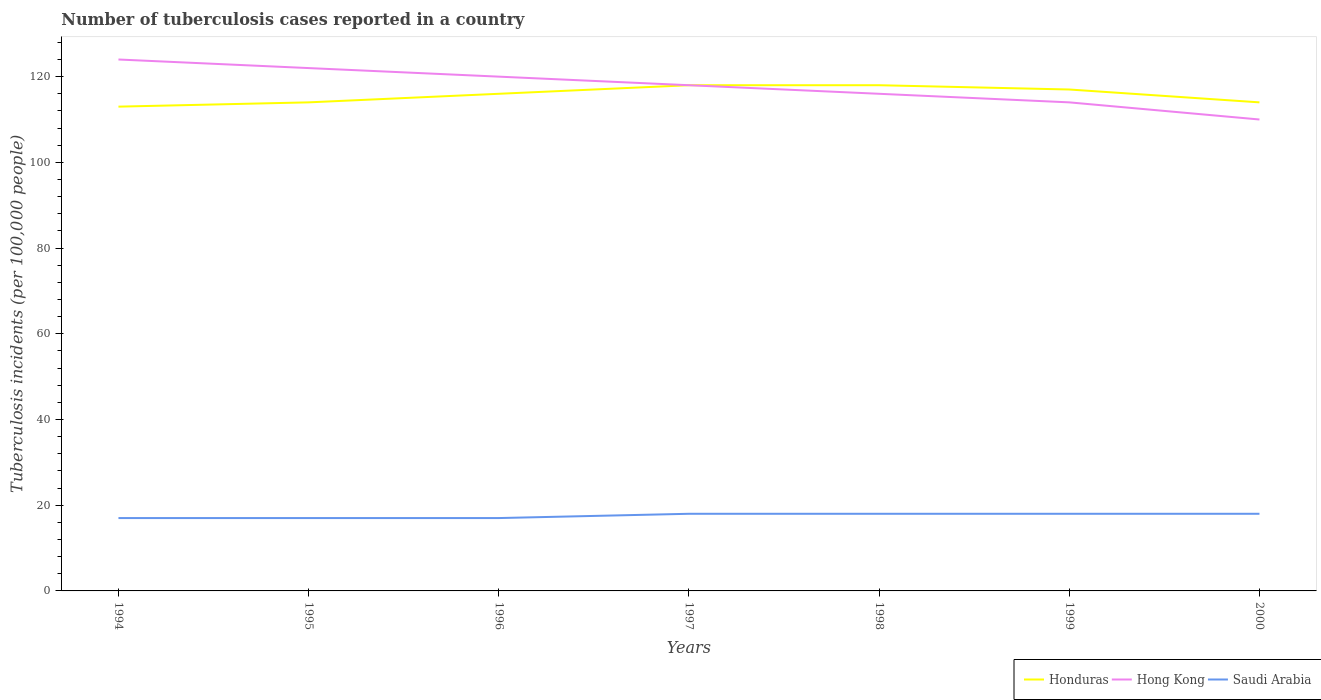How many different coloured lines are there?
Your answer should be compact. 3. Does the line corresponding to Honduras intersect with the line corresponding to Saudi Arabia?
Give a very brief answer. No. Is the number of lines equal to the number of legend labels?
Provide a succinct answer. Yes. Across all years, what is the maximum number of tuberculosis cases reported in in Hong Kong?
Make the answer very short. 110. What is the total number of tuberculosis cases reported in in Honduras in the graph?
Offer a very short reply. -1. What is the difference between the highest and the second highest number of tuberculosis cases reported in in Honduras?
Your answer should be compact. 5. Is the number of tuberculosis cases reported in in Hong Kong strictly greater than the number of tuberculosis cases reported in in Honduras over the years?
Provide a short and direct response. No. How many lines are there?
Offer a terse response. 3. What is the difference between two consecutive major ticks on the Y-axis?
Offer a terse response. 20. Are the values on the major ticks of Y-axis written in scientific E-notation?
Provide a succinct answer. No. Does the graph contain any zero values?
Your answer should be very brief. No. Does the graph contain grids?
Make the answer very short. No. Where does the legend appear in the graph?
Give a very brief answer. Bottom right. How are the legend labels stacked?
Provide a short and direct response. Horizontal. What is the title of the graph?
Make the answer very short. Number of tuberculosis cases reported in a country. Does "Slovak Republic" appear as one of the legend labels in the graph?
Make the answer very short. No. What is the label or title of the X-axis?
Offer a very short reply. Years. What is the label or title of the Y-axis?
Keep it short and to the point. Tuberculosis incidents (per 100,0 people). What is the Tuberculosis incidents (per 100,000 people) of Honduras in 1994?
Provide a succinct answer. 113. What is the Tuberculosis incidents (per 100,000 people) of Hong Kong in 1994?
Offer a very short reply. 124. What is the Tuberculosis incidents (per 100,000 people) in Saudi Arabia in 1994?
Offer a terse response. 17. What is the Tuberculosis incidents (per 100,000 people) in Honduras in 1995?
Your response must be concise. 114. What is the Tuberculosis incidents (per 100,000 people) in Hong Kong in 1995?
Your answer should be very brief. 122. What is the Tuberculosis incidents (per 100,000 people) of Saudi Arabia in 1995?
Offer a terse response. 17. What is the Tuberculosis incidents (per 100,000 people) in Honduras in 1996?
Your response must be concise. 116. What is the Tuberculosis incidents (per 100,000 people) in Hong Kong in 1996?
Make the answer very short. 120. What is the Tuberculosis incidents (per 100,000 people) in Honduras in 1997?
Provide a succinct answer. 118. What is the Tuberculosis incidents (per 100,000 people) in Hong Kong in 1997?
Give a very brief answer. 118. What is the Tuberculosis incidents (per 100,000 people) of Honduras in 1998?
Make the answer very short. 118. What is the Tuberculosis incidents (per 100,000 people) of Hong Kong in 1998?
Ensure brevity in your answer.  116. What is the Tuberculosis incidents (per 100,000 people) of Saudi Arabia in 1998?
Your answer should be very brief. 18. What is the Tuberculosis incidents (per 100,000 people) in Honduras in 1999?
Your response must be concise. 117. What is the Tuberculosis incidents (per 100,000 people) in Hong Kong in 1999?
Keep it short and to the point. 114. What is the Tuberculosis incidents (per 100,000 people) of Honduras in 2000?
Your answer should be very brief. 114. What is the Tuberculosis incidents (per 100,000 people) in Hong Kong in 2000?
Provide a short and direct response. 110. Across all years, what is the maximum Tuberculosis incidents (per 100,000 people) of Honduras?
Your response must be concise. 118. Across all years, what is the maximum Tuberculosis incidents (per 100,000 people) in Hong Kong?
Ensure brevity in your answer.  124. Across all years, what is the maximum Tuberculosis incidents (per 100,000 people) of Saudi Arabia?
Make the answer very short. 18. Across all years, what is the minimum Tuberculosis incidents (per 100,000 people) of Honduras?
Your answer should be very brief. 113. Across all years, what is the minimum Tuberculosis incidents (per 100,000 people) in Hong Kong?
Provide a succinct answer. 110. What is the total Tuberculosis incidents (per 100,000 people) of Honduras in the graph?
Give a very brief answer. 810. What is the total Tuberculosis incidents (per 100,000 people) of Hong Kong in the graph?
Keep it short and to the point. 824. What is the total Tuberculosis incidents (per 100,000 people) of Saudi Arabia in the graph?
Provide a short and direct response. 123. What is the difference between the Tuberculosis incidents (per 100,000 people) in Honduras in 1994 and that in 1995?
Provide a short and direct response. -1. What is the difference between the Tuberculosis incidents (per 100,000 people) of Hong Kong in 1994 and that in 1995?
Your response must be concise. 2. What is the difference between the Tuberculosis incidents (per 100,000 people) in Saudi Arabia in 1994 and that in 1995?
Your response must be concise. 0. What is the difference between the Tuberculosis incidents (per 100,000 people) of Saudi Arabia in 1994 and that in 1997?
Your answer should be compact. -1. What is the difference between the Tuberculosis incidents (per 100,000 people) of Honduras in 1994 and that in 2000?
Offer a terse response. -1. What is the difference between the Tuberculosis incidents (per 100,000 people) in Hong Kong in 1994 and that in 2000?
Provide a short and direct response. 14. What is the difference between the Tuberculosis incidents (per 100,000 people) in Hong Kong in 1995 and that in 1996?
Your response must be concise. 2. What is the difference between the Tuberculosis incidents (per 100,000 people) of Saudi Arabia in 1995 and that in 1997?
Ensure brevity in your answer.  -1. What is the difference between the Tuberculosis incidents (per 100,000 people) in Hong Kong in 1995 and that in 1998?
Provide a succinct answer. 6. What is the difference between the Tuberculosis incidents (per 100,000 people) of Saudi Arabia in 1995 and that in 1999?
Give a very brief answer. -1. What is the difference between the Tuberculosis incidents (per 100,000 people) of Saudi Arabia in 1995 and that in 2000?
Give a very brief answer. -1. What is the difference between the Tuberculosis incidents (per 100,000 people) of Saudi Arabia in 1996 and that in 1997?
Your response must be concise. -1. What is the difference between the Tuberculosis incidents (per 100,000 people) of Honduras in 1996 and that in 1998?
Make the answer very short. -2. What is the difference between the Tuberculosis incidents (per 100,000 people) of Hong Kong in 1996 and that in 1998?
Offer a very short reply. 4. What is the difference between the Tuberculosis incidents (per 100,000 people) in Saudi Arabia in 1996 and that in 1998?
Your answer should be compact. -1. What is the difference between the Tuberculosis incidents (per 100,000 people) in Honduras in 1996 and that in 1999?
Your answer should be compact. -1. What is the difference between the Tuberculosis incidents (per 100,000 people) in Saudi Arabia in 1996 and that in 1999?
Provide a succinct answer. -1. What is the difference between the Tuberculosis incidents (per 100,000 people) of Hong Kong in 1996 and that in 2000?
Make the answer very short. 10. What is the difference between the Tuberculosis incidents (per 100,000 people) in Saudi Arabia in 1996 and that in 2000?
Provide a succinct answer. -1. What is the difference between the Tuberculosis incidents (per 100,000 people) of Honduras in 1997 and that in 1998?
Your answer should be compact. 0. What is the difference between the Tuberculosis incidents (per 100,000 people) in Hong Kong in 1997 and that in 1998?
Provide a short and direct response. 2. What is the difference between the Tuberculosis incidents (per 100,000 people) of Saudi Arabia in 1997 and that in 1998?
Offer a terse response. 0. What is the difference between the Tuberculosis incidents (per 100,000 people) in Honduras in 1997 and that in 1999?
Your answer should be compact. 1. What is the difference between the Tuberculosis incidents (per 100,000 people) in Hong Kong in 1997 and that in 1999?
Provide a succinct answer. 4. What is the difference between the Tuberculosis incidents (per 100,000 people) of Saudi Arabia in 1997 and that in 1999?
Provide a succinct answer. 0. What is the difference between the Tuberculosis incidents (per 100,000 people) in Hong Kong in 1997 and that in 2000?
Keep it short and to the point. 8. What is the difference between the Tuberculosis incidents (per 100,000 people) in Saudi Arabia in 1997 and that in 2000?
Give a very brief answer. 0. What is the difference between the Tuberculosis incidents (per 100,000 people) of Hong Kong in 1998 and that in 2000?
Provide a short and direct response. 6. What is the difference between the Tuberculosis incidents (per 100,000 people) in Saudi Arabia in 1998 and that in 2000?
Give a very brief answer. 0. What is the difference between the Tuberculosis incidents (per 100,000 people) of Honduras in 1999 and that in 2000?
Ensure brevity in your answer.  3. What is the difference between the Tuberculosis incidents (per 100,000 people) of Honduras in 1994 and the Tuberculosis incidents (per 100,000 people) of Hong Kong in 1995?
Offer a very short reply. -9. What is the difference between the Tuberculosis incidents (per 100,000 people) of Honduras in 1994 and the Tuberculosis incidents (per 100,000 people) of Saudi Arabia in 1995?
Ensure brevity in your answer.  96. What is the difference between the Tuberculosis incidents (per 100,000 people) of Hong Kong in 1994 and the Tuberculosis incidents (per 100,000 people) of Saudi Arabia in 1995?
Keep it short and to the point. 107. What is the difference between the Tuberculosis incidents (per 100,000 people) in Honduras in 1994 and the Tuberculosis incidents (per 100,000 people) in Hong Kong in 1996?
Ensure brevity in your answer.  -7. What is the difference between the Tuberculosis incidents (per 100,000 people) of Honduras in 1994 and the Tuberculosis incidents (per 100,000 people) of Saudi Arabia in 1996?
Provide a short and direct response. 96. What is the difference between the Tuberculosis incidents (per 100,000 people) in Hong Kong in 1994 and the Tuberculosis incidents (per 100,000 people) in Saudi Arabia in 1996?
Provide a succinct answer. 107. What is the difference between the Tuberculosis incidents (per 100,000 people) of Hong Kong in 1994 and the Tuberculosis incidents (per 100,000 people) of Saudi Arabia in 1997?
Offer a very short reply. 106. What is the difference between the Tuberculosis incidents (per 100,000 people) in Honduras in 1994 and the Tuberculosis incidents (per 100,000 people) in Hong Kong in 1998?
Your answer should be very brief. -3. What is the difference between the Tuberculosis incidents (per 100,000 people) of Honduras in 1994 and the Tuberculosis incidents (per 100,000 people) of Saudi Arabia in 1998?
Provide a short and direct response. 95. What is the difference between the Tuberculosis incidents (per 100,000 people) of Hong Kong in 1994 and the Tuberculosis incidents (per 100,000 people) of Saudi Arabia in 1998?
Make the answer very short. 106. What is the difference between the Tuberculosis incidents (per 100,000 people) in Hong Kong in 1994 and the Tuberculosis incidents (per 100,000 people) in Saudi Arabia in 1999?
Make the answer very short. 106. What is the difference between the Tuberculosis incidents (per 100,000 people) of Honduras in 1994 and the Tuberculosis incidents (per 100,000 people) of Hong Kong in 2000?
Offer a very short reply. 3. What is the difference between the Tuberculosis incidents (per 100,000 people) in Hong Kong in 1994 and the Tuberculosis incidents (per 100,000 people) in Saudi Arabia in 2000?
Your answer should be very brief. 106. What is the difference between the Tuberculosis incidents (per 100,000 people) in Honduras in 1995 and the Tuberculosis incidents (per 100,000 people) in Saudi Arabia in 1996?
Keep it short and to the point. 97. What is the difference between the Tuberculosis incidents (per 100,000 people) in Hong Kong in 1995 and the Tuberculosis incidents (per 100,000 people) in Saudi Arabia in 1996?
Offer a very short reply. 105. What is the difference between the Tuberculosis incidents (per 100,000 people) of Honduras in 1995 and the Tuberculosis incidents (per 100,000 people) of Saudi Arabia in 1997?
Offer a very short reply. 96. What is the difference between the Tuberculosis incidents (per 100,000 people) of Hong Kong in 1995 and the Tuberculosis incidents (per 100,000 people) of Saudi Arabia in 1997?
Offer a terse response. 104. What is the difference between the Tuberculosis incidents (per 100,000 people) in Honduras in 1995 and the Tuberculosis incidents (per 100,000 people) in Hong Kong in 1998?
Offer a very short reply. -2. What is the difference between the Tuberculosis incidents (per 100,000 people) of Honduras in 1995 and the Tuberculosis incidents (per 100,000 people) of Saudi Arabia in 1998?
Offer a terse response. 96. What is the difference between the Tuberculosis incidents (per 100,000 people) of Hong Kong in 1995 and the Tuberculosis incidents (per 100,000 people) of Saudi Arabia in 1998?
Your response must be concise. 104. What is the difference between the Tuberculosis incidents (per 100,000 people) in Honduras in 1995 and the Tuberculosis incidents (per 100,000 people) in Saudi Arabia in 1999?
Your response must be concise. 96. What is the difference between the Tuberculosis incidents (per 100,000 people) of Hong Kong in 1995 and the Tuberculosis incidents (per 100,000 people) of Saudi Arabia in 1999?
Your response must be concise. 104. What is the difference between the Tuberculosis incidents (per 100,000 people) of Honduras in 1995 and the Tuberculosis incidents (per 100,000 people) of Saudi Arabia in 2000?
Give a very brief answer. 96. What is the difference between the Tuberculosis incidents (per 100,000 people) of Hong Kong in 1995 and the Tuberculosis incidents (per 100,000 people) of Saudi Arabia in 2000?
Ensure brevity in your answer.  104. What is the difference between the Tuberculosis incidents (per 100,000 people) of Honduras in 1996 and the Tuberculosis incidents (per 100,000 people) of Saudi Arabia in 1997?
Your response must be concise. 98. What is the difference between the Tuberculosis incidents (per 100,000 people) of Hong Kong in 1996 and the Tuberculosis incidents (per 100,000 people) of Saudi Arabia in 1997?
Give a very brief answer. 102. What is the difference between the Tuberculosis incidents (per 100,000 people) of Honduras in 1996 and the Tuberculosis incidents (per 100,000 people) of Hong Kong in 1998?
Your answer should be compact. 0. What is the difference between the Tuberculosis incidents (per 100,000 people) of Honduras in 1996 and the Tuberculosis incidents (per 100,000 people) of Saudi Arabia in 1998?
Offer a very short reply. 98. What is the difference between the Tuberculosis incidents (per 100,000 people) of Hong Kong in 1996 and the Tuberculosis incidents (per 100,000 people) of Saudi Arabia in 1998?
Your response must be concise. 102. What is the difference between the Tuberculosis incidents (per 100,000 people) in Hong Kong in 1996 and the Tuberculosis incidents (per 100,000 people) in Saudi Arabia in 1999?
Keep it short and to the point. 102. What is the difference between the Tuberculosis incidents (per 100,000 people) in Honduras in 1996 and the Tuberculosis incidents (per 100,000 people) in Hong Kong in 2000?
Offer a very short reply. 6. What is the difference between the Tuberculosis incidents (per 100,000 people) in Hong Kong in 1996 and the Tuberculosis incidents (per 100,000 people) in Saudi Arabia in 2000?
Your answer should be very brief. 102. What is the difference between the Tuberculosis incidents (per 100,000 people) of Honduras in 1997 and the Tuberculosis incidents (per 100,000 people) of Hong Kong in 1998?
Give a very brief answer. 2. What is the difference between the Tuberculosis incidents (per 100,000 people) in Honduras in 1997 and the Tuberculosis incidents (per 100,000 people) in Saudi Arabia in 1998?
Your answer should be very brief. 100. What is the difference between the Tuberculosis incidents (per 100,000 people) in Honduras in 1997 and the Tuberculosis incidents (per 100,000 people) in Hong Kong in 2000?
Keep it short and to the point. 8. What is the difference between the Tuberculosis incidents (per 100,000 people) in Honduras in 1997 and the Tuberculosis incidents (per 100,000 people) in Saudi Arabia in 2000?
Your answer should be very brief. 100. What is the difference between the Tuberculosis incidents (per 100,000 people) of Honduras in 1998 and the Tuberculosis incidents (per 100,000 people) of Hong Kong in 1999?
Make the answer very short. 4. What is the difference between the Tuberculosis incidents (per 100,000 people) of Honduras in 1998 and the Tuberculosis incidents (per 100,000 people) of Saudi Arabia in 1999?
Your response must be concise. 100. What is the difference between the Tuberculosis incidents (per 100,000 people) in Honduras in 1998 and the Tuberculosis incidents (per 100,000 people) in Hong Kong in 2000?
Provide a succinct answer. 8. What is the difference between the Tuberculosis incidents (per 100,000 people) in Honduras in 1998 and the Tuberculosis incidents (per 100,000 people) in Saudi Arabia in 2000?
Provide a succinct answer. 100. What is the difference between the Tuberculosis incidents (per 100,000 people) of Hong Kong in 1998 and the Tuberculosis incidents (per 100,000 people) of Saudi Arabia in 2000?
Your answer should be very brief. 98. What is the difference between the Tuberculosis incidents (per 100,000 people) of Hong Kong in 1999 and the Tuberculosis incidents (per 100,000 people) of Saudi Arabia in 2000?
Ensure brevity in your answer.  96. What is the average Tuberculosis incidents (per 100,000 people) of Honduras per year?
Ensure brevity in your answer.  115.71. What is the average Tuberculosis incidents (per 100,000 people) in Hong Kong per year?
Your response must be concise. 117.71. What is the average Tuberculosis incidents (per 100,000 people) in Saudi Arabia per year?
Offer a very short reply. 17.57. In the year 1994, what is the difference between the Tuberculosis incidents (per 100,000 people) in Honduras and Tuberculosis incidents (per 100,000 people) in Hong Kong?
Your answer should be very brief. -11. In the year 1994, what is the difference between the Tuberculosis incidents (per 100,000 people) in Honduras and Tuberculosis incidents (per 100,000 people) in Saudi Arabia?
Give a very brief answer. 96. In the year 1994, what is the difference between the Tuberculosis incidents (per 100,000 people) of Hong Kong and Tuberculosis incidents (per 100,000 people) of Saudi Arabia?
Ensure brevity in your answer.  107. In the year 1995, what is the difference between the Tuberculosis incidents (per 100,000 people) of Honduras and Tuberculosis incidents (per 100,000 people) of Saudi Arabia?
Your answer should be very brief. 97. In the year 1995, what is the difference between the Tuberculosis incidents (per 100,000 people) of Hong Kong and Tuberculosis incidents (per 100,000 people) of Saudi Arabia?
Your answer should be compact. 105. In the year 1996, what is the difference between the Tuberculosis incidents (per 100,000 people) in Hong Kong and Tuberculosis incidents (per 100,000 people) in Saudi Arabia?
Offer a very short reply. 103. In the year 1997, what is the difference between the Tuberculosis incidents (per 100,000 people) in Honduras and Tuberculosis incidents (per 100,000 people) in Hong Kong?
Provide a short and direct response. 0. In the year 1998, what is the difference between the Tuberculosis incidents (per 100,000 people) in Honduras and Tuberculosis incidents (per 100,000 people) in Hong Kong?
Offer a very short reply. 2. In the year 1998, what is the difference between the Tuberculosis incidents (per 100,000 people) of Honduras and Tuberculosis incidents (per 100,000 people) of Saudi Arabia?
Provide a short and direct response. 100. In the year 1998, what is the difference between the Tuberculosis incidents (per 100,000 people) of Hong Kong and Tuberculosis incidents (per 100,000 people) of Saudi Arabia?
Provide a succinct answer. 98. In the year 1999, what is the difference between the Tuberculosis incidents (per 100,000 people) of Honduras and Tuberculosis incidents (per 100,000 people) of Saudi Arabia?
Offer a very short reply. 99. In the year 1999, what is the difference between the Tuberculosis incidents (per 100,000 people) of Hong Kong and Tuberculosis incidents (per 100,000 people) of Saudi Arabia?
Offer a very short reply. 96. In the year 2000, what is the difference between the Tuberculosis incidents (per 100,000 people) of Honduras and Tuberculosis incidents (per 100,000 people) of Saudi Arabia?
Your answer should be very brief. 96. In the year 2000, what is the difference between the Tuberculosis incidents (per 100,000 people) in Hong Kong and Tuberculosis incidents (per 100,000 people) in Saudi Arabia?
Make the answer very short. 92. What is the ratio of the Tuberculosis incidents (per 100,000 people) of Hong Kong in 1994 to that in 1995?
Provide a short and direct response. 1.02. What is the ratio of the Tuberculosis incidents (per 100,000 people) of Honduras in 1994 to that in 1996?
Ensure brevity in your answer.  0.97. What is the ratio of the Tuberculosis incidents (per 100,000 people) of Hong Kong in 1994 to that in 1996?
Your response must be concise. 1.03. What is the ratio of the Tuberculosis incidents (per 100,000 people) in Honduras in 1994 to that in 1997?
Make the answer very short. 0.96. What is the ratio of the Tuberculosis incidents (per 100,000 people) in Hong Kong in 1994 to that in 1997?
Offer a terse response. 1.05. What is the ratio of the Tuberculosis incidents (per 100,000 people) of Saudi Arabia in 1994 to that in 1997?
Offer a very short reply. 0.94. What is the ratio of the Tuberculosis incidents (per 100,000 people) in Honduras in 1994 to that in 1998?
Provide a short and direct response. 0.96. What is the ratio of the Tuberculosis incidents (per 100,000 people) in Hong Kong in 1994 to that in 1998?
Keep it short and to the point. 1.07. What is the ratio of the Tuberculosis incidents (per 100,000 people) in Honduras in 1994 to that in 1999?
Your answer should be very brief. 0.97. What is the ratio of the Tuberculosis incidents (per 100,000 people) in Hong Kong in 1994 to that in 1999?
Give a very brief answer. 1.09. What is the ratio of the Tuberculosis incidents (per 100,000 people) of Hong Kong in 1994 to that in 2000?
Offer a very short reply. 1.13. What is the ratio of the Tuberculosis incidents (per 100,000 people) of Saudi Arabia in 1994 to that in 2000?
Offer a very short reply. 0.94. What is the ratio of the Tuberculosis incidents (per 100,000 people) in Honduras in 1995 to that in 1996?
Provide a short and direct response. 0.98. What is the ratio of the Tuberculosis incidents (per 100,000 people) of Hong Kong in 1995 to that in 1996?
Offer a very short reply. 1.02. What is the ratio of the Tuberculosis incidents (per 100,000 people) in Saudi Arabia in 1995 to that in 1996?
Give a very brief answer. 1. What is the ratio of the Tuberculosis incidents (per 100,000 people) in Honduras in 1995 to that in 1997?
Your answer should be compact. 0.97. What is the ratio of the Tuberculosis incidents (per 100,000 people) of Hong Kong in 1995 to that in 1997?
Make the answer very short. 1.03. What is the ratio of the Tuberculosis incidents (per 100,000 people) in Saudi Arabia in 1995 to that in 1997?
Provide a short and direct response. 0.94. What is the ratio of the Tuberculosis incidents (per 100,000 people) in Honduras in 1995 to that in 1998?
Keep it short and to the point. 0.97. What is the ratio of the Tuberculosis incidents (per 100,000 people) of Hong Kong in 1995 to that in 1998?
Keep it short and to the point. 1.05. What is the ratio of the Tuberculosis incidents (per 100,000 people) in Honduras in 1995 to that in 1999?
Ensure brevity in your answer.  0.97. What is the ratio of the Tuberculosis incidents (per 100,000 people) in Hong Kong in 1995 to that in 1999?
Give a very brief answer. 1.07. What is the ratio of the Tuberculosis incidents (per 100,000 people) in Saudi Arabia in 1995 to that in 1999?
Ensure brevity in your answer.  0.94. What is the ratio of the Tuberculosis incidents (per 100,000 people) in Honduras in 1995 to that in 2000?
Your response must be concise. 1. What is the ratio of the Tuberculosis incidents (per 100,000 people) in Hong Kong in 1995 to that in 2000?
Ensure brevity in your answer.  1.11. What is the ratio of the Tuberculosis incidents (per 100,000 people) in Saudi Arabia in 1995 to that in 2000?
Your answer should be very brief. 0.94. What is the ratio of the Tuberculosis incidents (per 100,000 people) of Honduras in 1996 to that in 1997?
Give a very brief answer. 0.98. What is the ratio of the Tuberculosis incidents (per 100,000 people) of Hong Kong in 1996 to that in 1997?
Make the answer very short. 1.02. What is the ratio of the Tuberculosis incidents (per 100,000 people) in Saudi Arabia in 1996 to that in 1997?
Ensure brevity in your answer.  0.94. What is the ratio of the Tuberculosis incidents (per 100,000 people) of Honduras in 1996 to that in 1998?
Make the answer very short. 0.98. What is the ratio of the Tuberculosis incidents (per 100,000 people) in Hong Kong in 1996 to that in 1998?
Offer a very short reply. 1.03. What is the ratio of the Tuberculosis incidents (per 100,000 people) in Saudi Arabia in 1996 to that in 1998?
Keep it short and to the point. 0.94. What is the ratio of the Tuberculosis incidents (per 100,000 people) of Honduras in 1996 to that in 1999?
Make the answer very short. 0.99. What is the ratio of the Tuberculosis incidents (per 100,000 people) of Hong Kong in 1996 to that in 1999?
Your answer should be compact. 1.05. What is the ratio of the Tuberculosis incidents (per 100,000 people) of Saudi Arabia in 1996 to that in 1999?
Give a very brief answer. 0.94. What is the ratio of the Tuberculosis incidents (per 100,000 people) in Honduras in 1996 to that in 2000?
Provide a short and direct response. 1.02. What is the ratio of the Tuberculosis incidents (per 100,000 people) of Honduras in 1997 to that in 1998?
Provide a short and direct response. 1. What is the ratio of the Tuberculosis incidents (per 100,000 people) of Hong Kong in 1997 to that in 1998?
Make the answer very short. 1.02. What is the ratio of the Tuberculosis incidents (per 100,000 people) of Honduras in 1997 to that in 1999?
Offer a terse response. 1.01. What is the ratio of the Tuberculosis incidents (per 100,000 people) in Hong Kong in 1997 to that in 1999?
Provide a short and direct response. 1.04. What is the ratio of the Tuberculosis incidents (per 100,000 people) in Honduras in 1997 to that in 2000?
Your answer should be very brief. 1.04. What is the ratio of the Tuberculosis incidents (per 100,000 people) of Hong Kong in 1997 to that in 2000?
Provide a succinct answer. 1.07. What is the ratio of the Tuberculosis incidents (per 100,000 people) in Saudi Arabia in 1997 to that in 2000?
Provide a succinct answer. 1. What is the ratio of the Tuberculosis incidents (per 100,000 people) of Honduras in 1998 to that in 1999?
Give a very brief answer. 1.01. What is the ratio of the Tuberculosis incidents (per 100,000 people) of Hong Kong in 1998 to that in 1999?
Ensure brevity in your answer.  1.02. What is the ratio of the Tuberculosis incidents (per 100,000 people) of Honduras in 1998 to that in 2000?
Make the answer very short. 1.04. What is the ratio of the Tuberculosis incidents (per 100,000 people) in Hong Kong in 1998 to that in 2000?
Your answer should be very brief. 1.05. What is the ratio of the Tuberculosis incidents (per 100,000 people) in Saudi Arabia in 1998 to that in 2000?
Your response must be concise. 1. What is the ratio of the Tuberculosis incidents (per 100,000 people) in Honduras in 1999 to that in 2000?
Give a very brief answer. 1.03. What is the ratio of the Tuberculosis incidents (per 100,000 people) in Hong Kong in 1999 to that in 2000?
Your answer should be very brief. 1.04. What is the difference between the highest and the lowest Tuberculosis incidents (per 100,000 people) in Honduras?
Provide a short and direct response. 5. 